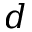<formula> <loc_0><loc_0><loc_500><loc_500>d</formula> 